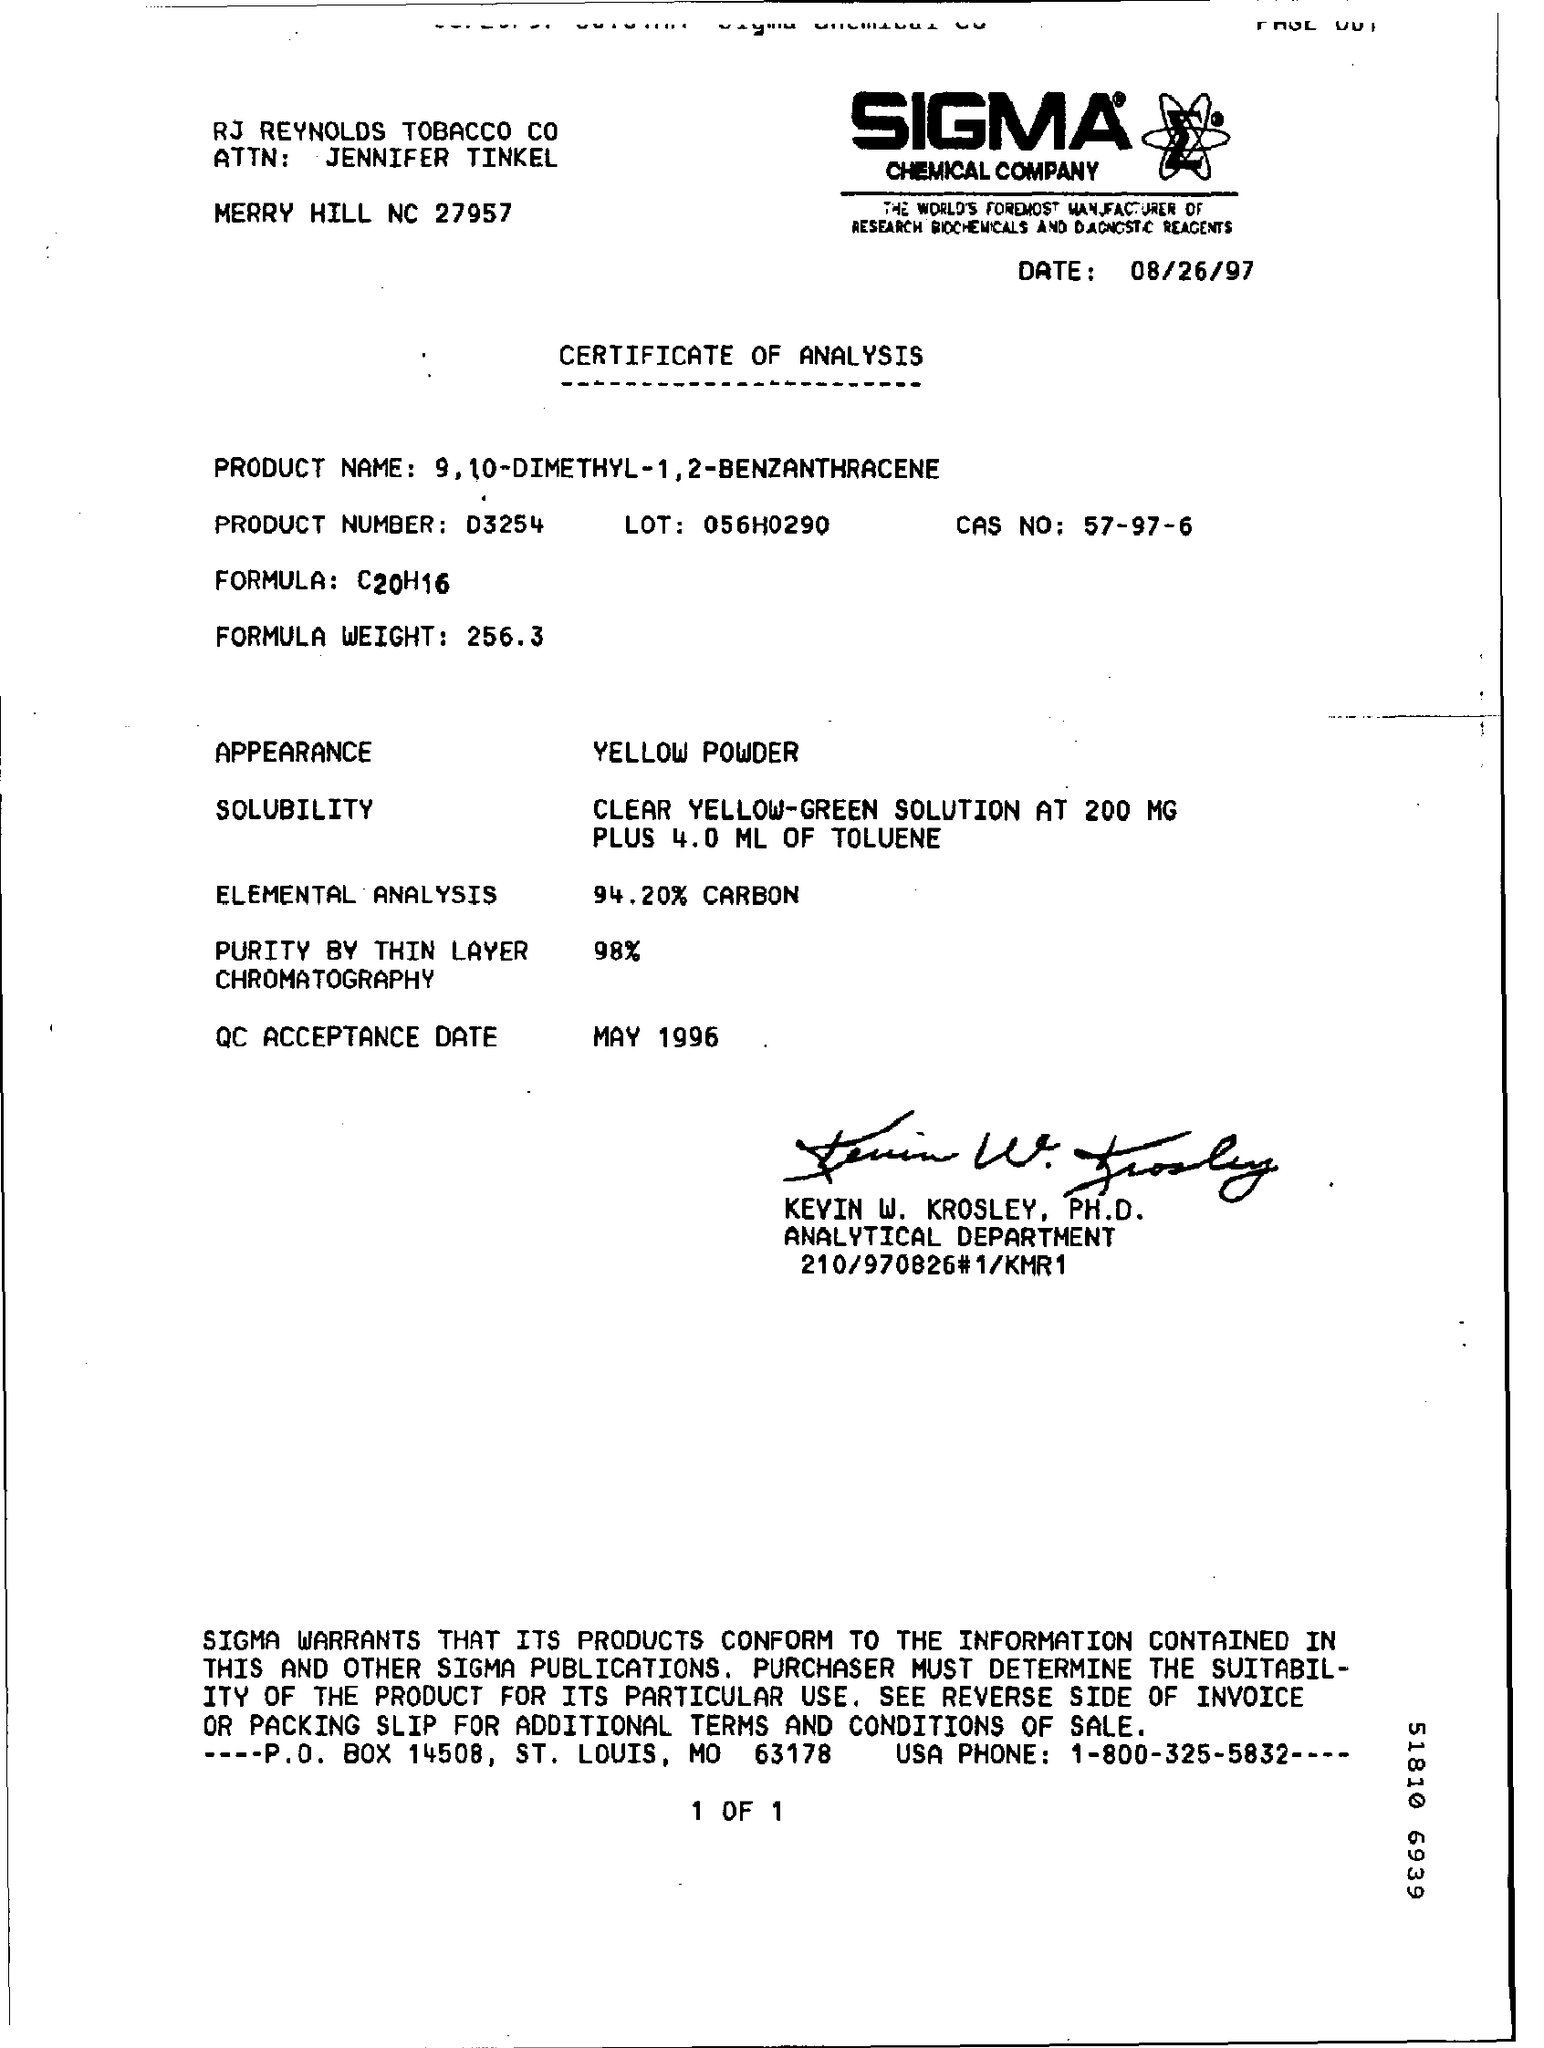Indicate a few pertinent items in this graphic. The product number is D3254. On August 26, 1997, the date was. The formula for a compound is a chemical representation of the elements that make up the compound and the ratio in which they are combined. In the case of C20H16, the formula represents a compound made up of carbon and hydrogen atoms in a specific ratio that has not been determined. The document is a Certificate of Analysis. The CAS number for a chemical compound is 57-97-6. 